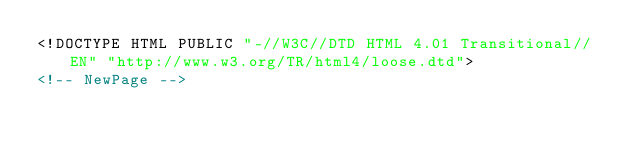Convert code to text. <code><loc_0><loc_0><loc_500><loc_500><_HTML_><!DOCTYPE HTML PUBLIC "-//W3C//DTD HTML 4.01 Transitional//EN" "http://www.w3.org/TR/html4/loose.dtd">
<!-- NewPage --></code> 